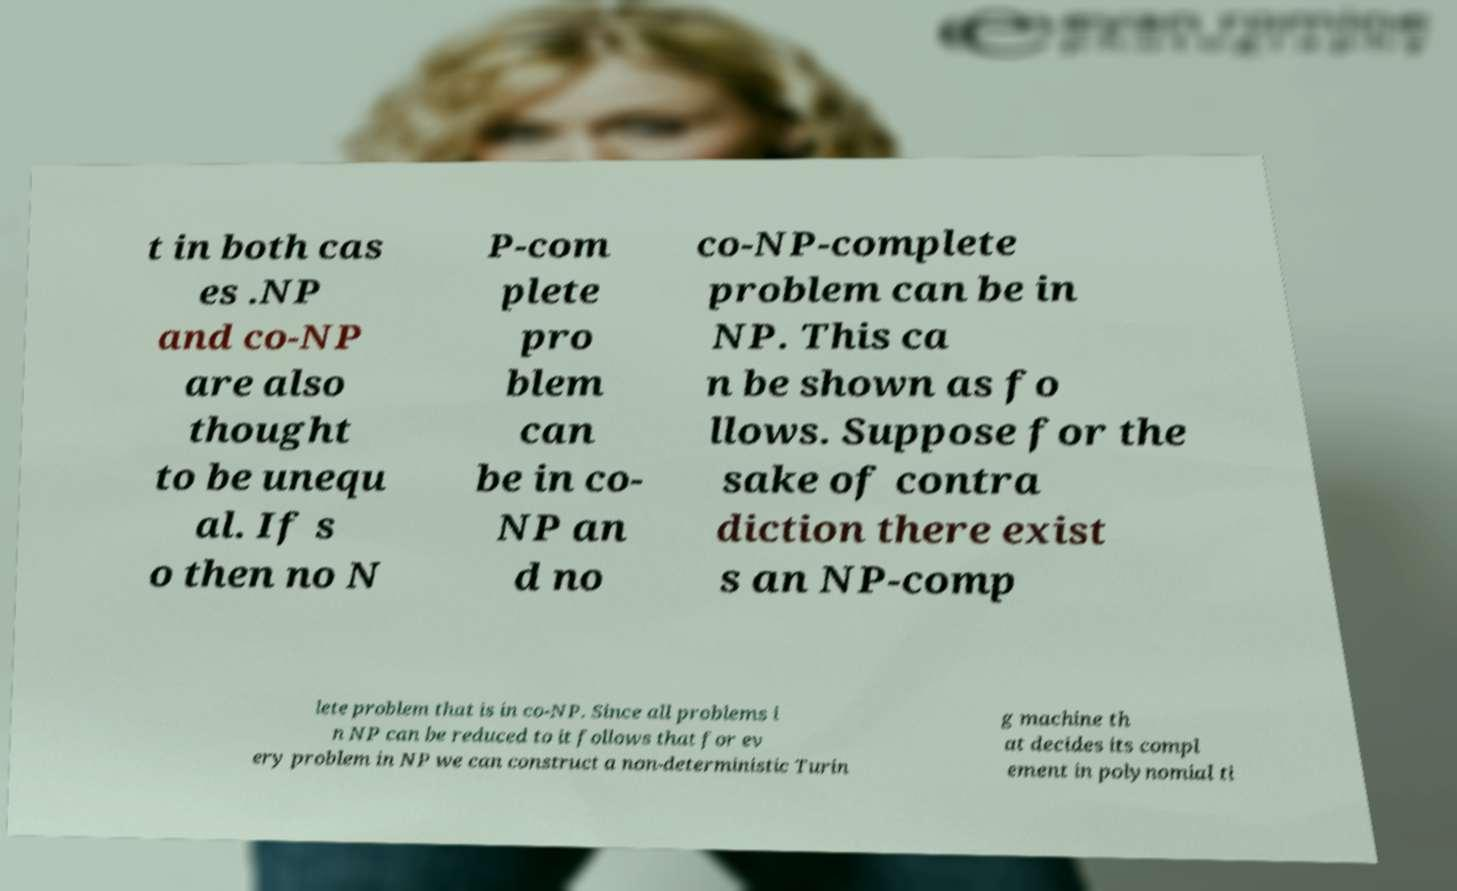Could you assist in decoding the text presented in this image and type it out clearly? t in both cas es .NP and co-NP are also thought to be unequ al. If s o then no N P-com plete pro blem can be in co- NP an d no co-NP-complete problem can be in NP. This ca n be shown as fo llows. Suppose for the sake of contra diction there exist s an NP-comp lete problem that is in co-NP. Since all problems i n NP can be reduced to it follows that for ev ery problem in NP we can construct a non-deterministic Turin g machine th at decides its compl ement in polynomial ti 